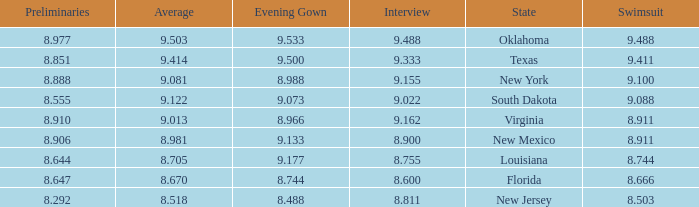 what's the evening gown where preliminaries is 8.977 9.533. Could you help me parse every detail presented in this table? {'header': ['Preliminaries', 'Average', 'Evening Gown', 'Interview', 'State', 'Swimsuit'], 'rows': [['8.977', '9.503', '9.533', '9.488', 'Oklahoma', '9.488'], ['8.851', '9.414', '9.500', '9.333', 'Texas', '9.411'], ['8.888', '9.081', '8.988', '9.155', 'New York', '9.100'], ['8.555', '9.122', '9.073', '9.022', 'South Dakota', '9.088'], ['8.910', '9.013', '8.966', '9.162', 'Virginia', '8.911'], ['8.906', '8.981', '9.133', '8.900', 'New Mexico', '8.911'], ['8.644', '8.705', '9.177', '8.755', 'Louisiana', '8.744'], ['8.647', '8.670', '8.744', '8.600', 'Florida', '8.666'], ['8.292', '8.518', '8.488', '8.811', 'New Jersey', '8.503']]} 